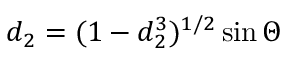Convert formula to latex. <formula><loc_0><loc_0><loc_500><loc_500>d _ { 2 } = ( 1 - d _ { 2 } ^ { 3 } ) ^ { 1 / 2 } \sin \Theta</formula> 